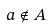Convert formula to latex. <formula><loc_0><loc_0><loc_500><loc_500>a \notin A</formula> 